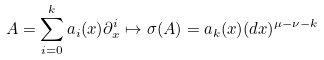Convert formula to latex. <formula><loc_0><loc_0><loc_500><loc_500>A = \sum _ { i = 0 } ^ { k } a _ { i } ( x ) \partial _ { x } ^ { i } \mapsto \sigma ( A ) = a _ { k } ( x ) ( d x ) ^ { \mu - \nu - k }</formula> 